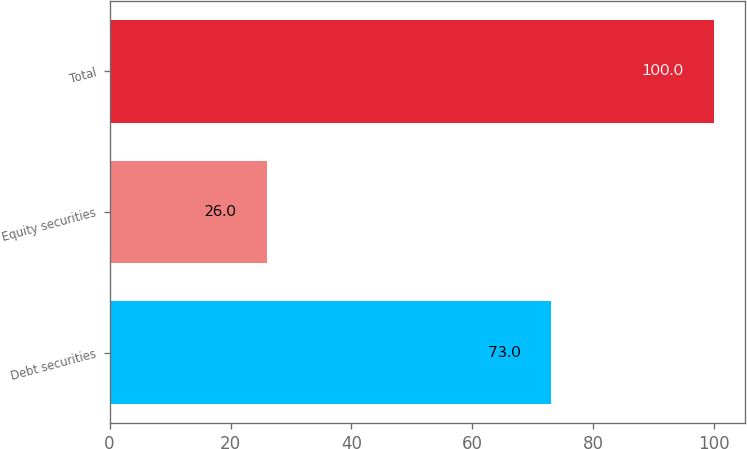Convert chart to OTSL. <chart><loc_0><loc_0><loc_500><loc_500><bar_chart><fcel>Debt securities<fcel>Equity securities<fcel>Total<nl><fcel>73<fcel>26<fcel>100<nl></chart> 